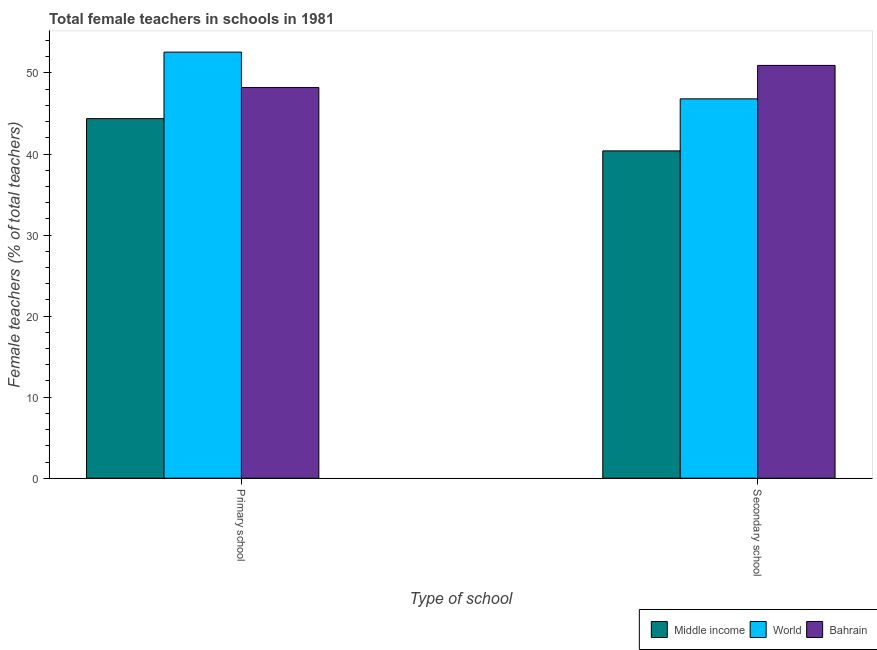Are the number of bars per tick equal to the number of legend labels?
Offer a terse response. Yes. Are the number of bars on each tick of the X-axis equal?
Your response must be concise. Yes. How many bars are there on the 1st tick from the left?
Your answer should be compact. 3. How many bars are there on the 2nd tick from the right?
Give a very brief answer. 3. What is the label of the 2nd group of bars from the left?
Your answer should be compact. Secondary school. What is the percentage of female teachers in primary schools in Bahrain?
Your response must be concise. 48.2. Across all countries, what is the maximum percentage of female teachers in primary schools?
Keep it short and to the point. 52.57. Across all countries, what is the minimum percentage of female teachers in secondary schools?
Offer a terse response. 40.38. In which country was the percentage of female teachers in primary schools maximum?
Provide a succinct answer. World. In which country was the percentage of female teachers in secondary schools minimum?
Ensure brevity in your answer.  Middle income. What is the total percentage of female teachers in primary schools in the graph?
Give a very brief answer. 145.13. What is the difference between the percentage of female teachers in primary schools in Middle income and that in World?
Ensure brevity in your answer.  -8.2. What is the difference between the percentage of female teachers in primary schools in Bahrain and the percentage of female teachers in secondary schools in Middle income?
Your answer should be compact. 7.81. What is the average percentage of female teachers in secondary schools per country?
Your response must be concise. 46.04. What is the difference between the percentage of female teachers in primary schools and percentage of female teachers in secondary schools in Middle income?
Give a very brief answer. 3.98. In how many countries, is the percentage of female teachers in primary schools greater than 44 %?
Keep it short and to the point. 3. What is the ratio of the percentage of female teachers in secondary schools in Bahrain to that in World?
Ensure brevity in your answer.  1.09. Is the percentage of female teachers in primary schools in Bahrain less than that in World?
Provide a succinct answer. Yes. In how many countries, is the percentage of female teachers in primary schools greater than the average percentage of female teachers in primary schools taken over all countries?
Provide a short and direct response. 1. What does the 3rd bar from the left in Primary school represents?
Give a very brief answer. Bahrain. What does the 1st bar from the right in Primary school represents?
Provide a short and direct response. Bahrain. What is the difference between two consecutive major ticks on the Y-axis?
Provide a succinct answer. 10. Does the graph contain grids?
Keep it short and to the point. No. Where does the legend appear in the graph?
Offer a terse response. Bottom right. What is the title of the graph?
Provide a short and direct response. Total female teachers in schools in 1981. Does "Suriname" appear as one of the legend labels in the graph?
Provide a succinct answer. No. What is the label or title of the X-axis?
Offer a terse response. Type of school. What is the label or title of the Y-axis?
Your answer should be very brief. Female teachers (% of total teachers). What is the Female teachers (% of total teachers) in Middle income in Primary school?
Ensure brevity in your answer.  44.36. What is the Female teachers (% of total teachers) in World in Primary school?
Offer a very short reply. 52.57. What is the Female teachers (% of total teachers) of Bahrain in Primary school?
Keep it short and to the point. 48.2. What is the Female teachers (% of total teachers) in Middle income in Secondary school?
Your answer should be compact. 40.38. What is the Female teachers (% of total teachers) in World in Secondary school?
Your response must be concise. 46.8. What is the Female teachers (% of total teachers) in Bahrain in Secondary school?
Keep it short and to the point. 50.93. Across all Type of school, what is the maximum Female teachers (% of total teachers) in Middle income?
Your answer should be very brief. 44.36. Across all Type of school, what is the maximum Female teachers (% of total teachers) in World?
Provide a short and direct response. 52.57. Across all Type of school, what is the maximum Female teachers (% of total teachers) of Bahrain?
Provide a short and direct response. 50.93. Across all Type of school, what is the minimum Female teachers (% of total teachers) of Middle income?
Provide a short and direct response. 40.38. Across all Type of school, what is the minimum Female teachers (% of total teachers) of World?
Your response must be concise. 46.8. Across all Type of school, what is the minimum Female teachers (% of total teachers) of Bahrain?
Your answer should be very brief. 48.2. What is the total Female teachers (% of total teachers) in Middle income in the graph?
Make the answer very short. 84.75. What is the total Female teachers (% of total teachers) in World in the graph?
Make the answer very short. 99.37. What is the total Female teachers (% of total teachers) in Bahrain in the graph?
Offer a terse response. 99.12. What is the difference between the Female teachers (% of total teachers) in Middle income in Primary school and that in Secondary school?
Ensure brevity in your answer.  3.98. What is the difference between the Female teachers (% of total teachers) in World in Primary school and that in Secondary school?
Offer a terse response. 5.76. What is the difference between the Female teachers (% of total teachers) in Bahrain in Primary school and that in Secondary school?
Provide a short and direct response. -2.73. What is the difference between the Female teachers (% of total teachers) of Middle income in Primary school and the Female teachers (% of total teachers) of World in Secondary school?
Offer a very short reply. -2.44. What is the difference between the Female teachers (% of total teachers) in Middle income in Primary school and the Female teachers (% of total teachers) in Bahrain in Secondary school?
Ensure brevity in your answer.  -6.57. What is the difference between the Female teachers (% of total teachers) of World in Primary school and the Female teachers (% of total teachers) of Bahrain in Secondary school?
Give a very brief answer. 1.64. What is the average Female teachers (% of total teachers) of Middle income per Type of school?
Provide a succinct answer. 42.37. What is the average Female teachers (% of total teachers) in World per Type of school?
Your response must be concise. 49.69. What is the average Female teachers (% of total teachers) of Bahrain per Type of school?
Provide a short and direct response. 49.56. What is the difference between the Female teachers (% of total teachers) in Middle income and Female teachers (% of total teachers) in World in Primary school?
Offer a terse response. -8.2. What is the difference between the Female teachers (% of total teachers) in Middle income and Female teachers (% of total teachers) in Bahrain in Primary school?
Your answer should be very brief. -3.83. What is the difference between the Female teachers (% of total teachers) in World and Female teachers (% of total teachers) in Bahrain in Primary school?
Your response must be concise. 4.37. What is the difference between the Female teachers (% of total teachers) of Middle income and Female teachers (% of total teachers) of World in Secondary school?
Your answer should be very brief. -6.42. What is the difference between the Female teachers (% of total teachers) in Middle income and Female teachers (% of total teachers) in Bahrain in Secondary school?
Offer a very short reply. -10.54. What is the difference between the Female teachers (% of total teachers) of World and Female teachers (% of total teachers) of Bahrain in Secondary school?
Your answer should be very brief. -4.12. What is the ratio of the Female teachers (% of total teachers) of Middle income in Primary school to that in Secondary school?
Your answer should be compact. 1.1. What is the ratio of the Female teachers (% of total teachers) of World in Primary school to that in Secondary school?
Keep it short and to the point. 1.12. What is the ratio of the Female teachers (% of total teachers) in Bahrain in Primary school to that in Secondary school?
Your answer should be very brief. 0.95. What is the difference between the highest and the second highest Female teachers (% of total teachers) in Middle income?
Offer a very short reply. 3.98. What is the difference between the highest and the second highest Female teachers (% of total teachers) in World?
Ensure brevity in your answer.  5.76. What is the difference between the highest and the second highest Female teachers (% of total teachers) in Bahrain?
Provide a short and direct response. 2.73. What is the difference between the highest and the lowest Female teachers (% of total teachers) of Middle income?
Make the answer very short. 3.98. What is the difference between the highest and the lowest Female teachers (% of total teachers) of World?
Provide a succinct answer. 5.76. What is the difference between the highest and the lowest Female teachers (% of total teachers) of Bahrain?
Provide a succinct answer. 2.73. 